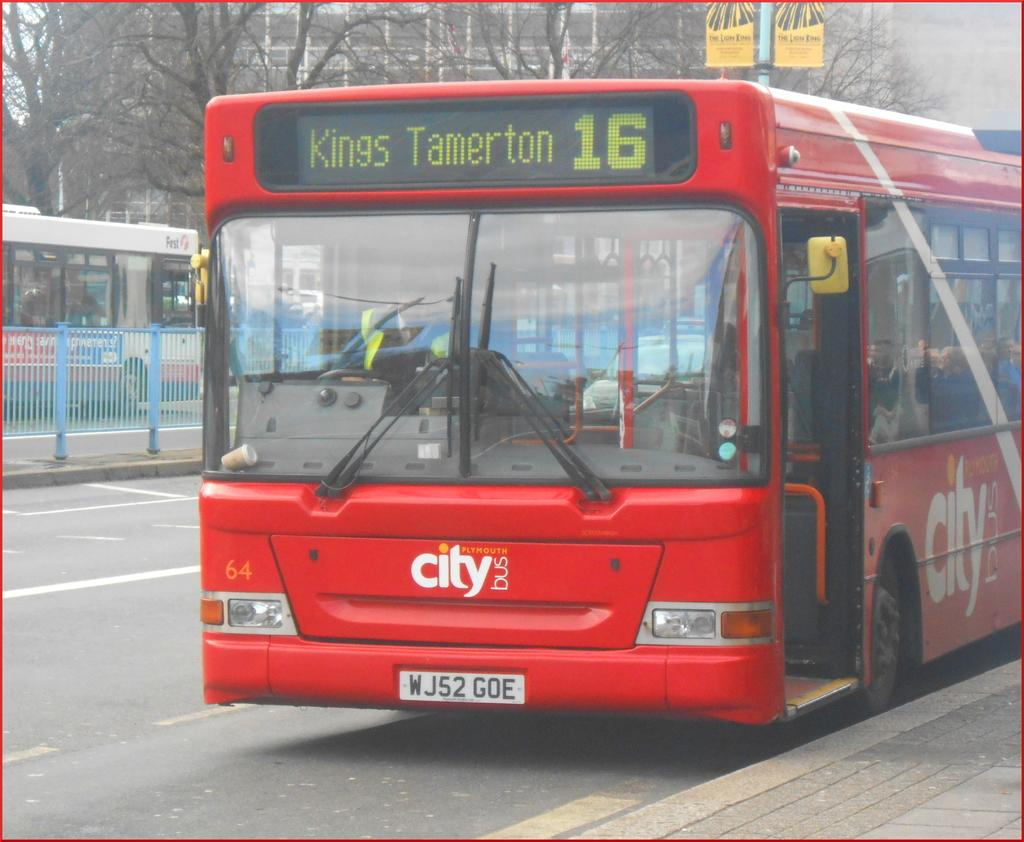<image>
Give a short and clear explanation of the subsequent image. A city bus is going to the location Kings Tamerton. 